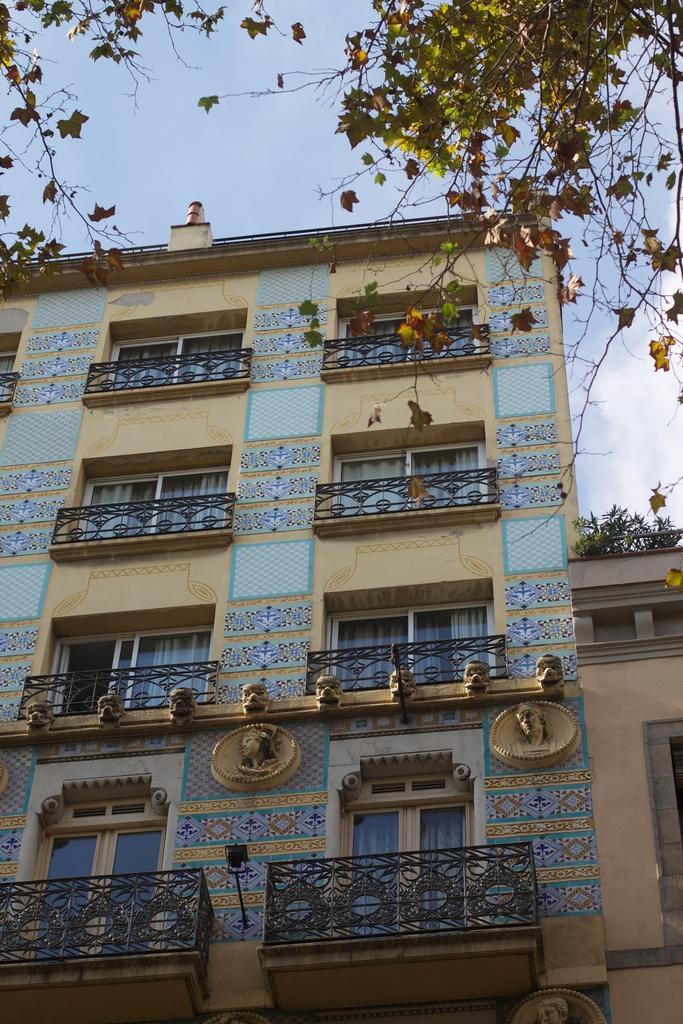Please provide a concise description of this image. In this image there are buildings, railing and there are some plants and trees and sculptures on the building and there are lights, at the top there is sky. 